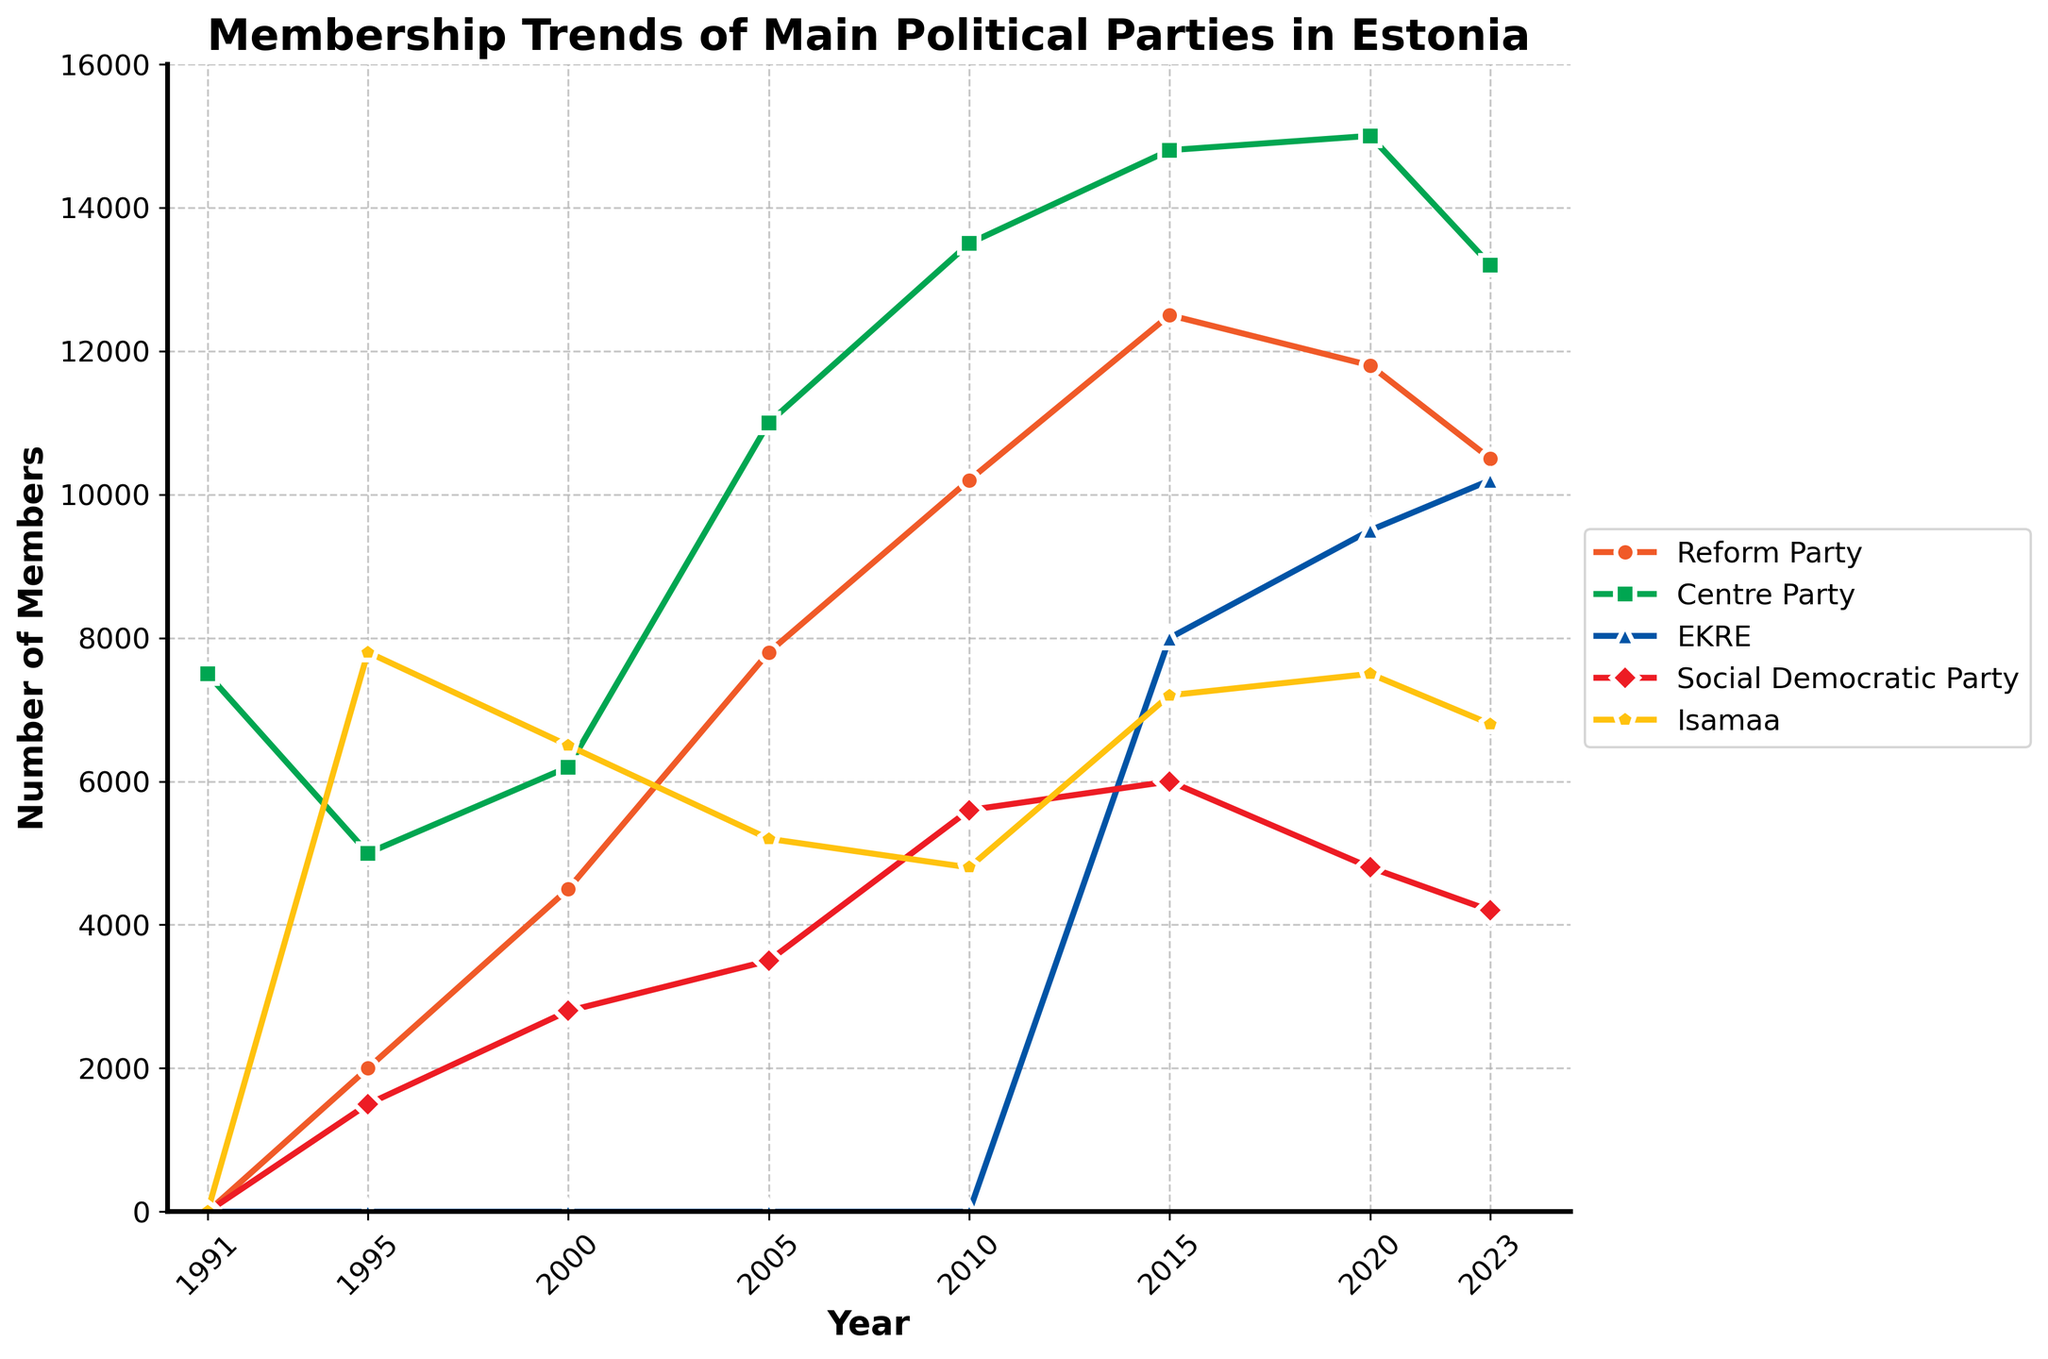What is the trend of membership in the Reform Party between 1995 and 2023? The plot shows an upward trend for the Reform Party's membership from 2000 to 2015, peaking at 12,500 in 2015. From 2015 onward, membership gradually decreases to 10,500 in 2023.
Answer: Increasing until 2015, then decreasing Which political party had the highest membership in 2010? By visually comparing the lines at the 2010 mark, the Centre Party had the highest membership with a value of 13,500.
Answer: Centre Party How did the membership of EKRE change from 2015 to 2023? EKRE's membership started at 8,000 in 2015 and increased steadily to 10,200 in 2023.
Answer: Increased Which party experienced the largest drop in membership between 2020 and 2023? Comparing the slopes between the two years, the Social Democratic Party showed the steepest decline, from 4,800 to 4,200.
Answer: Social Democratic Party What was the total combined membership of all parties in 2000? Add the membership numbers for each party in 2000: 4,500 (Reform) + 6,200 (Centre) + 0 (EKRE) + 2,800 (Social Democratic) + 6,500 (Isamaa) = 20,000.
Answer: 20,000 Which party had the smallest change in membership from 1995 to 2000? From visually inspecting the relative change, Isamaa experienced the smallest change, reducing from 7,800 to 6,500 members.
Answer: Isamaa In which period did the Social Democratic Party membership peak? The plot indicates the highest point for the Social Democratic Party is in 2015, with 6,000 members.
Answer: 2015 Compare the membership trends of the Centre Party and the Reform Party. The Centre Party has maintained a consistently high and increasing membership trend, while the Reform Party shows significant growth until 2015 followed by a decline.
Answer: Centre Party consistently increasing, Reform Party peaked then declined Did any party’s membership exceed 15,000 members at any point in time? No party's line crossed the 15,000 mark throughout the displayed timeline.
Answer: No Which party’s membership was the lowest in 2023? The Social Democratic Party had the lowest membership in 2023 with 4,200 members.
Answer: Social Democratic Party 